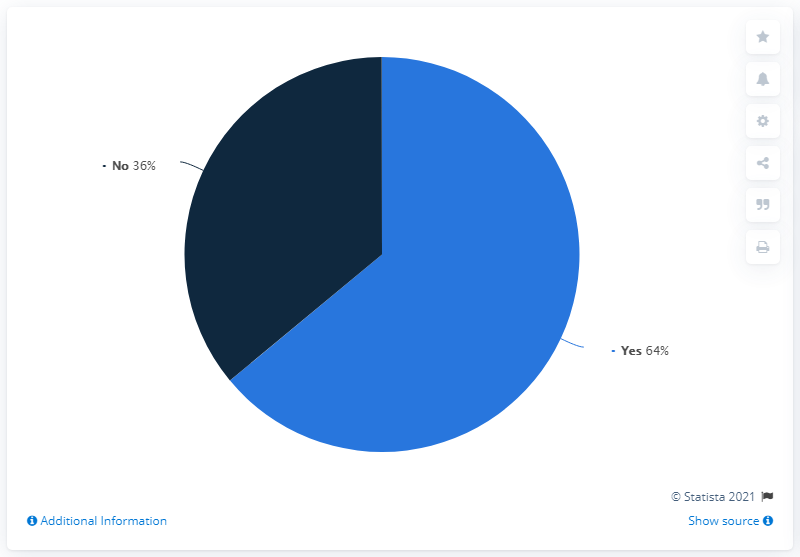Indicate a few pertinent items in this graphic. The color of "Yes" in a pie segment is light blue. What is the distinction between "yes" and "no" in a pie segment? 